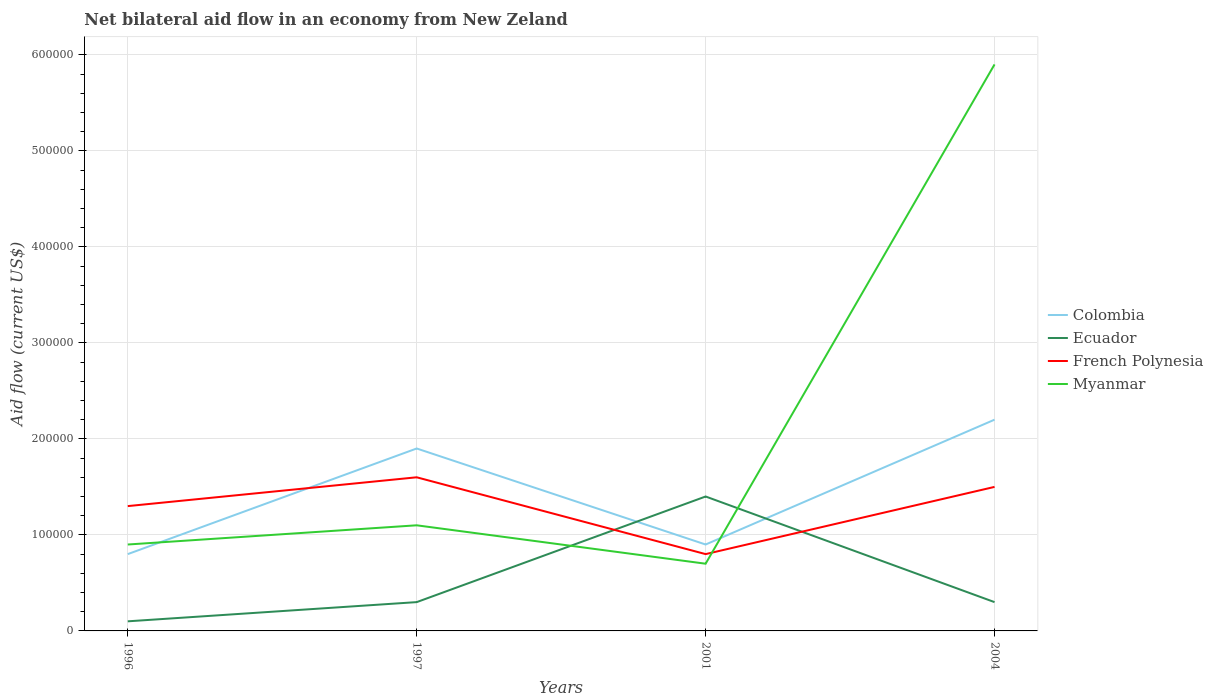How many different coloured lines are there?
Provide a short and direct response. 4. Does the line corresponding to Myanmar intersect with the line corresponding to Colombia?
Provide a succinct answer. Yes. Is the number of lines equal to the number of legend labels?
Offer a very short reply. Yes. In which year was the net bilateral aid flow in Colombia maximum?
Your answer should be very brief. 1996. What is the difference between the highest and the lowest net bilateral aid flow in Colombia?
Your answer should be very brief. 2. Is the net bilateral aid flow in Colombia strictly greater than the net bilateral aid flow in Myanmar over the years?
Make the answer very short. No. How many lines are there?
Offer a terse response. 4. How many years are there in the graph?
Your answer should be compact. 4. Are the values on the major ticks of Y-axis written in scientific E-notation?
Your answer should be compact. No. Does the graph contain grids?
Your answer should be compact. Yes. Where does the legend appear in the graph?
Give a very brief answer. Center right. How many legend labels are there?
Make the answer very short. 4. What is the title of the graph?
Give a very brief answer. Net bilateral aid flow in an economy from New Zeland. Does "Tonga" appear as one of the legend labels in the graph?
Provide a succinct answer. No. What is the label or title of the X-axis?
Ensure brevity in your answer.  Years. What is the Aid flow (current US$) of Colombia in 1996?
Provide a succinct answer. 8.00e+04. What is the Aid flow (current US$) in Ecuador in 1996?
Offer a terse response. 10000. What is the Aid flow (current US$) of French Polynesia in 1996?
Make the answer very short. 1.30e+05. What is the Aid flow (current US$) of Myanmar in 1996?
Provide a succinct answer. 9.00e+04. What is the Aid flow (current US$) of Colombia in 1997?
Keep it short and to the point. 1.90e+05. What is the Aid flow (current US$) of Ecuador in 1997?
Your answer should be compact. 3.00e+04. What is the Aid flow (current US$) in Myanmar in 1997?
Provide a succinct answer. 1.10e+05. What is the Aid flow (current US$) in Colombia in 2001?
Give a very brief answer. 9.00e+04. What is the Aid flow (current US$) in Ecuador in 2001?
Your response must be concise. 1.40e+05. What is the Aid flow (current US$) in French Polynesia in 2001?
Offer a terse response. 8.00e+04. What is the Aid flow (current US$) of Myanmar in 2004?
Provide a short and direct response. 5.90e+05. Across all years, what is the maximum Aid flow (current US$) in French Polynesia?
Provide a short and direct response. 1.60e+05. Across all years, what is the maximum Aid flow (current US$) of Myanmar?
Ensure brevity in your answer.  5.90e+05. Across all years, what is the minimum Aid flow (current US$) in Ecuador?
Provide a short and direct response. 10000. Across all years, what is the minimum Aid flow (current US$) of Myanmar?
Offer a terse response. 7.00e+04. What is the total Aid flow (current US$) in Colombia in the graph?
Your response must be concise. 5.80e+05. What is the total Aid flow (current US$) in Ecuador in the graph?
Make the answer very short. 2.10e+05. What is the total Aid flow (current US$) of French Polynesia in the graph?
Offer a very short reply. 5.20e+05. What is the total Aid flow (current US$) in Myanmar in the graph?
Provide a succinct answer. 8.60e+05. What is the difference between the Aid flow (current US$) in Colombia in 1996 and that in 1997?
Your response must be concise. -1.10e+05. What is the difference between the Aid flow (current US$) of French Polynesia in 1996 and that in 1997?
Your response must be concise. -3.00e+04. What is the difference between the Aid flow (current US$) of Colombia in 1996 and that in 2001?
Your response must be concise. -10000. What is the difference between the Aid flow (current US$) in Myanmar in 1996 and that in 2001?
Offer a very short reply. 2.00e+04. What is the difference between the Aid flow (current US$) in Colombia in 1996 and that in 2004?
Ensure brevity in your answer.  -1.40e+05. What is the difference between the Aid flow (current US$) of Ecuador in 1996 and that in 2004?
Your response must be concise. -2.00e+04. What is the difference between the Aid flow (current US$) of Myanmar in 1996 and that in 2004?
Your answer should be compact. -5.00e+05. What is the difference between the Aid flow (current US$) in French Polynesia in 1997 and that in 2001?
Ensure brevity in your answer.  8.00e+04. What is the difference between the Aid flow (current US$) of Ecuador in 1997 and that in 2004?
Offer a terse response. 0. What is the difference between the Aid flow (current US$) of French Polynesia in 1997 and that in 2004?
Provide a short and direct response. 10000. What is the difference between the Aid flow (current US$) of Myanmar in 1997 and that in 2004?
Keep it short and to the point. -4.80e+05. What is the difference between the Aid flow (current US$) in Colombia in 2001 and that in 2004?
Provide a short and direct response. -1.30e+05. What is the difference between the Aid flow (current US$) of Ecuador in 2001 and that in 2004?
Your response must be concise. 1.10e+05. What is the difference between the Aid flow (current US$) of French Polynesia in 2001 and that in 2004?
Your answer should be very brief. -7.00e+04. What is the difference between the Aid flow (current US$) in Myanmar in 2001 and that in 2004?
Give a very brief answer. -5.20e+05. What is the difference between the Aid flow (current US$) in Colombia in 1996 and the Aid flow (current US$) in Ecuador in 1997?
Provide a succinct answer. 5.00e+04. What is the difference between the Aid flow (current US$) of Colombia in 1996 and the Aid flow (current US$) of French Polynesia in 1997?
Give a very brief answer. -8.00e+04. What is the difference between the Aid flow (current US$) in Colombia in 1996 and the Aid flow (current US$) in Myanmar in 1997?
Keep it short and to the point. -3.00e+04. What is the difference between the Aid flow (current US$) of Colombia in 1996 and the Aid flow (current US$) of French Polynesia in 2001?
Provide a short and direct response. 0. What is the difference between the Aid flow (current US$) in Colombia in 1996 and the Aid flow (current US$) in Myanmar in 2001?
Your response must be concise. 10000. What is the difference between the Aid flow (current US$) in Colombia in 1996 and the Aid flow (current US$) in Ecuador in 2004?
Ensure brevity in your answer.  5.00e+04. What is the difference between the Aid flow (current US$) in Colombia in 1996 and the Aid flow (current US$) in Myanmar in 2004?
Your response must be concise. -5.10e+05. What is the difference between the Aid flow (current US$) in Ecuador in 1996 and the Aid flow (current US$) in Myanmar in 2004?
Your response must be concise. -5.80e+05. What is the difference between the Aid flow (current US$) in French Polynesia in 1996 and the Aid flow (current US$) in Myanmar in 2004?
Offer a very short reply. -4.60e+05. What is the difference between the Aid flow (current US$) in Colombia in 1997 and the Aid flow (current US$) in French Polynesia in 2001?
Offer a very short reply. 1.10e+05. What is the difference between the Aid flow (current US$) in Ecuador in 1997 and the Aid flow (current US$) in French Polynesia in 2001?
Give a very brief answer. -5.00e+04. What is the difference between the Aid flow (current US$) in Ecuador in 1997 and the Aid flow (current US$) in Myanmar in 2001?
Your answer should be very brief. -4.00e+04. What is the difference between the Aid flow (current US$) of Colombia in 1997 and the Aid flow (current US$) of French Polynesia in 2004?
Your answer should be compact. 4.00e+04. What is the difference between the Aid flow (current US$) in Colombia in 1997 and the Aid flow (current US$) in Myanmar in 2004?
Give a very brief answer. -4.00e+05. What is the difference between the Aid flow (current US$) of Ecuador in 1997 and the Aid flow (current US$) of French Polynesia in 2004?
Give a very brief answer. -1.20e+05. What is the difference between the Aid flow (current US$) in Ecuador in 1997 and the Aid flow (current US$) in Myanmar in 2004?
Give a very brief answer. -5.60e+05. What is the difference between the Aid flow (current US$) of French Polynesia in 1997 and the Aid flow (current US$) of Myanmar in 2004?
Your response must be concise. -4.30e+05. What is the difference between the Aid flow (current US$) of Colombia in 2001 and the Aid flow (current US$) of Ecuador in 2004?
Keep it short and to the point. 6.00e+04. What is the difference between the Aid flow (current US$) of Colombia in 2001 and the Aid flow (current US$) of French Polynesia in 2004?
Keep it short and to the point. -6.00e+04. What is the difference between the Aid flow (current US$) in Colombia in 2001 and the Aid flow (current US$) in Myanmar in 2004?
Ensure brevity in your answer.  -5.00e+05. What is the difference between the Aid flow (current US$) in Ecuador in 2001 and the Aid flow (current US$) in French Polynesia in 2004?
Your answer should be very brief. -10000. What is the difference between the Aid flow (current US$) of Ecuador in 2001 and the Aid flow (current US$) of Myanmar in 2004?
Your answer should be very brief. -4.50e+05. What is the difference between the Aid flow (current US$) of French Polynesia in 2001 and the Aid flow (current US$) of Myanmar in 2004?
Ensure brevity in your answer.  -5.10e+05. What is the average Aid flow (current US$) of Colombia per year?
Give a very brief answer. 1.45e+05. What is the average Aid flow (current US$) in Ecuador per year?
Offer a terse response. 5.25e+04. What is the average Aid flow (current US$) of French Polynesia per year?
Your answer should be very brief. 1.30e+05. What is the average Aid flow (current US$) in Myanmar per year?
Your response must be concise. 2.15e+05. In the year 1996, what is the difference between the Aid flow (current US$) in Ecuador and Aid flow (current US$) in Myanmar?
Offer a terse response. -8.00e+04. In the year 1996, what is the difference between the Aid flow (current US$) in French Polynesia and Aid flow (current US$) in Myanmar?
Provide a succinct answer. 4.00e+04. In the year 1997, what is the difference between the Aid flow (current US$) in Colombia and Aid flow (current US$) in French Polynesia?
Your answer should be compact. 3.00e+04. In the year 1997, what is the difference between the Aid flow (current US$) of French Polynesia and Aid flow (current US$) of Myanmar?
Ensure brevity in your answer.  5.00e+04. In the year 2001, what is the difference between the Aid flow (current US$) of Colombia and Aid flow (current US$) of Ecuador?
Ensure brevity in your answer.  -5.00e+04. In the year 2001, what is the difference between the Aid flow (current US$) of Colombia and Aid flow (current US$) of French Polynesia?
Provide a succinct answer. 10000. In the year 2001, what is the difference between the Aid flow (current US$) of Colombia and Aid flow (current US$) of Myanmar?
Make the answer very short. 2.00e+04. In the year 2001, what is the difference between the Aid flow (current US$) in Ecuador and Aid flow (current US$) in French Polynesia?
Offer a very short reply. 6.00e+04. In the year 2004, what is the difference between the Aid flow (current US$) in Colombia and Aid flow (current US$) in Ecuador?
Your response must be concise. 1.90e+05. In the year 2004, what is the difference between the Aid flow (current US$) of Colombia and Aid flow (current US$) of French Polynesia?
Give a very brief answer. 7.00e+04. In the year 2004, what is the difference between the Aid flow (current US$) of Colombia and Aid flow (current US$) of Myanmar?
Your response must be concise. -3.70e+05. In the year 2004, what is the difference between the Aid flow (current US$) in Ecuador and Aid flow (current US$) in Myanmar?
Make the answer very short. -5.60e+05. In the year 2004, what is the difference between the Aid flow (current US$) of French Polynesia and Aid flow (current US$) of Myanmar?
Your response must be concise. -4.40e+05. What is the ratio of the Aid flow (current US$) in Colombia in 1996 to that in 1997?
Make the answer very short. 0.42. What is the ratio of the Aid flow (current US$) in Ecuador in 1996 to that in 1997?
Give a very brief answer. 0.33. What is the ratio of the Aid flow (current US$) in French Polynesia in 1996 to that in 1997?
Your answer should be compact. 0.81. What is the ratio of the Aid flow (current US$) in Myanmar in 1996 to that in 1997?
Provide a short and direct response. 0.82. What is the ratio of the Aid flow (current US$) of Colombia in 1996 to that in 2001?
Your response must be concise. 0.89. What is the ratio of the Aid flow (current US$) in Ecuador in 1996 to that in 2001?
Offer a very short reply. 0.07. What is the ratio of the Aid flow (current US$) of French Polynesia in 1996 to that in 2001?
Your answer should be very brief. 1.62. What is the ratio of the Aid flow (current US$) in Myanmar in 1996 to that in 2001?
Give a very brief answer. 1.29. What is the ratio of the Aid flow (current US$) in Colombia in 1996 to that in 2004?
Give a very brief answer. 0.36. What is the ratio of the Aid flow (current US$) of Ecuador in 1996 to that in 2004?
Offer a very short reply. 0.33. What is the ratio of the Aid flow (current US$) in French Polynesia in 1996 to that in 2004?
Give a very brief answer. 0.87. What is the ratio of the Aid flow (current US$) in Myanmar in 1996 to that in 2004?
Ensure brevity in your answer.  0.15. What is the ratio of the Aid flow (current US$) of Colombia in 1997 to that in 2001?
Keep it short and to the point. 2.11. What is the ratio of the Aid flow (current US$) in Ecuador in 1997 to that in 2001?
Ensure brevity in your answer.  0.21. What is the ratio of the Aid flow (current US$) of French Polynesia in 1997 to that in 2001?
Ensure brevity in your answer.  2. What is the ratio of the Aid flow (current US$) in Myanmar in 1997 to that in 2001?
Offer a very short reply. 1.57. What is the ratio of the Aid flow (current US$) of Colombia in 1997 to that in 2004?
Keep it short and to the point. 0.86. What is the ratio of the Aid flow (current US$) in Ecuador in 1997 to that in 2004?
Your answer should be very brief. 1. What is the ratio of the Aid flow (current US$) of French Polynesia in 1997 to that in 2004?
Provide a short and direct response. 1.07. What is the ratio of the Aid flow (current US$) in Myanmar in 1997 to that in 2004?
Your response must be concise. 0.19. What is the ratio of the Aid flow (current US$) of Colombia in 2001 to that in 2004?
Your response must be concise. 0.41. What is the ratio of the Aid flow (current US$) of Ecuador in 2001 to that in 2004?
Your answer should be very brief. 4.67. What is the ratio of the Aid flow (current US$) in French Polynesia in 2001 to that in 2004?
Ensure brevity in your answer.  0.53. What is the ratio of the Aid flow (current US$) in Myanmar in 2001 to that in 2004?
Your answer should be very brief. 0.12. What is the difference between the highest and the second highest Aid flow (current US$) of Ecuador?
Provide a short and direct response. 1.10e+05. What is the difference between the highest and the second highest Aid flow (current US$) in French Polynesia?
Make the answer very short. 10000. What is the difference between the highest and the second highest Aid flow (current US$) in Myanmar?
Ensure brevity in your answer.  4.80e+05. What is the difference between the highest and the lowest Aid flow (current US$) in Colombia?
Ensure brevity in your answer.  1.40e+05. What is the difference between the highest and the lowest Aid flow (current US$) in Myanmar?
Keep it short and to the point. 5.20e+05. 